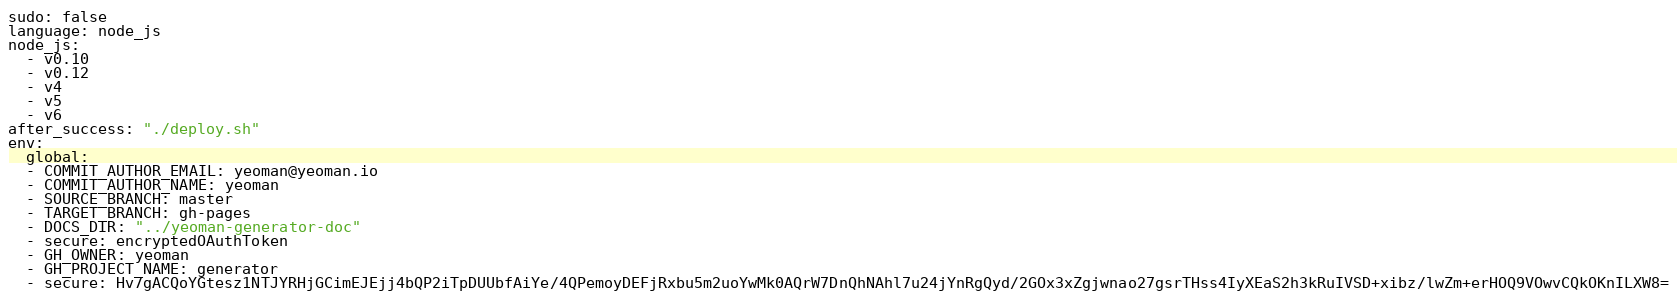<code> <loc_0><loc_0><loc_500><loc_500><_YAML_>sudo: false
language: node_js
node_js:
  - v0.10
  - v0.12
  - v4
  - v5
  - v6
after_success: "./deploy.sh"
env:
  global:
  - COMMIT_AUTHOR_EMAIL: yeoman@yeoman.io
  - COMMIT_AUTHOR_NAME: yeoman
  - SOURCE_BRANCH: master
  - TARGET_BRANCH: gh-pages
  - DOCS_DIR: "../yeoman-generator-doc"
  - secure: encryptedOAuthToken
  - GH_OWNER: yeoman
  - GH_PROJECT_NAME: generator
  - secure: Hv7gACQoYGtesz1NTJYRHjGCimEJEjj4bQP2iTpDUUbfAiYe/4QPemoyDEFjRxbu5m2uoYwMk0AQrW7DnQhNAhl7u24jYnRgQyd/2GOx3xZgjwnao27gsrTHss4IyXEaS2h3kRuIVSD+xibz/lwZm+erHOQ9VOwvCQkOKnILXW8=
</code> 